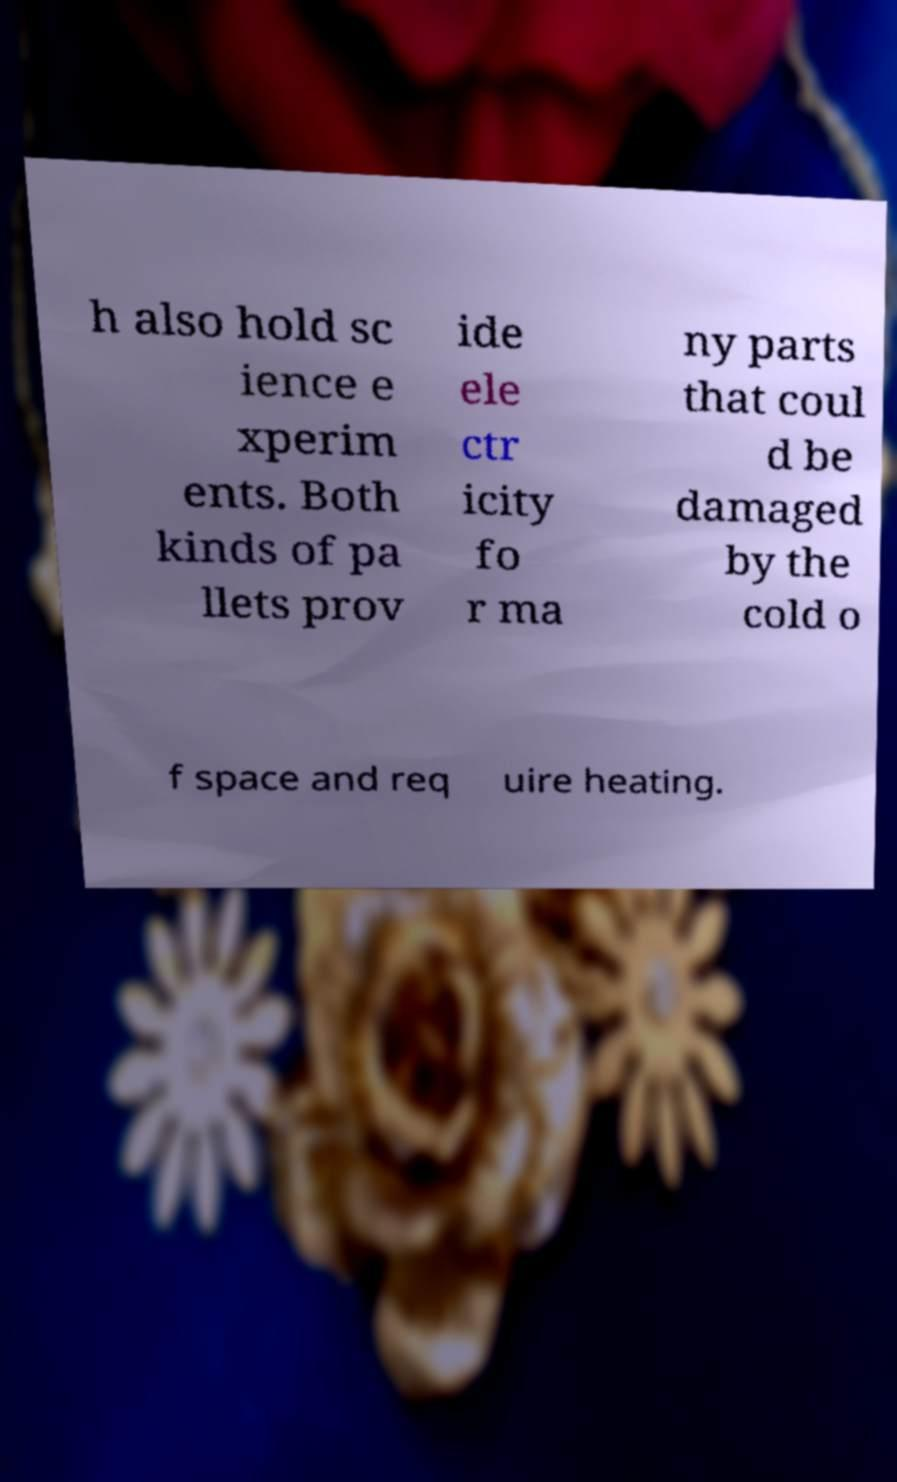Can you read and provide the text displayed in the image?This photo seems to have some interesting text. Can you extract and type it out for me? h also hold sc ience e xperim ents. Both kinds of pa llets prov ide ele ctr icity fo r ma ny parts that coul d be damaged by the cold o f space and req uire heating. 